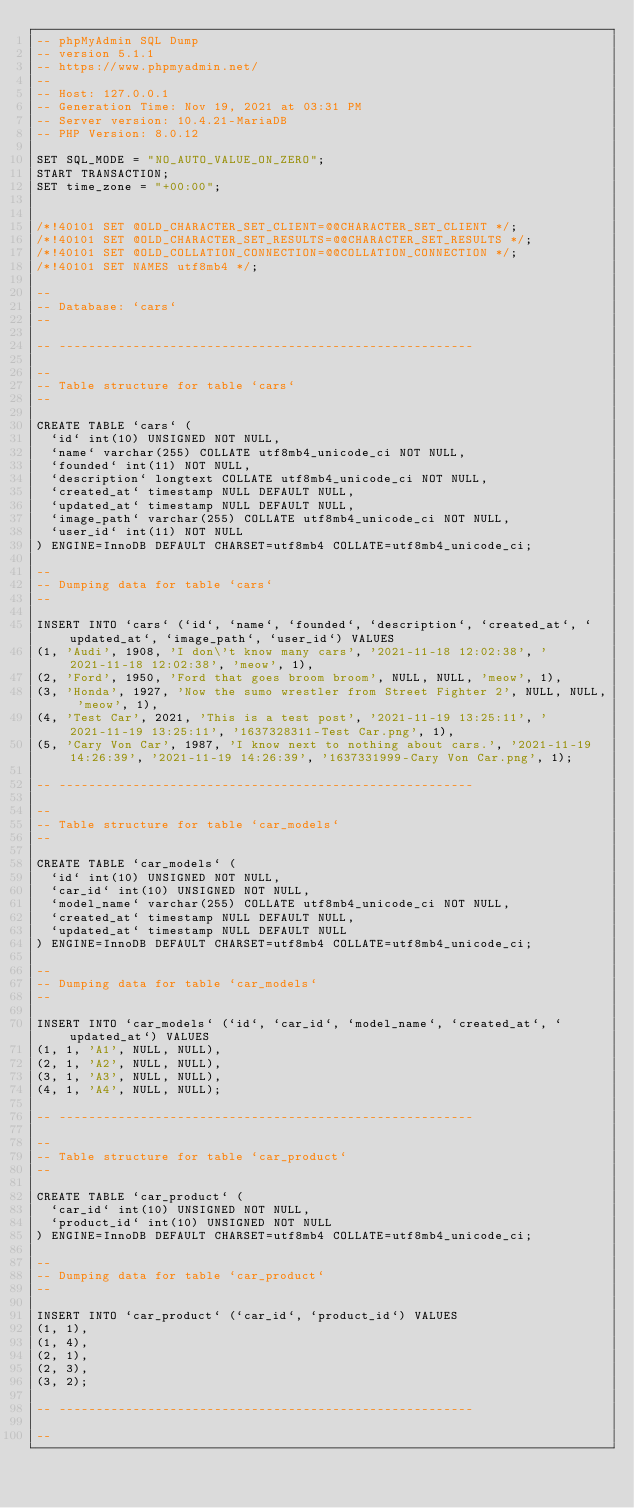Convert code to text. <code><loc_0><loc_0><loc_500><loc_500><_SQL_>-- phpMyAdmin SQL Dump
-- version 5.1.1
-- https://www.phpmyadmin.net/
--
-- Host: 127.0.0.1
-- Generation Time: Nov 19, 2021 at 03:31 PM
-- Server version: 10.4.21-MariaDB
-- PHP Version: 8.0.12

SET SQL_MODE = "NO_AUTO_VALUE_ON_ZERO";
START TRANSACTION;
SET time_zone = "+00:00";


/*!40101 SET @OLD_CHARACTER_SET_CLIENT=@@CHARACTER_SET_CLIENT */;
/*!40101 SET @OLD_CHARACTER_SET_RESULTS=@@CHARACTER_SET_RESULTS */;
/*!40101 SET @OLD_COLLATION_CONNECTION=@@COLLATION_CONNECTION */;
/*!40101 SET NAMES utf8mb4 */;

--
-- Database: `cars`
--

-- --------------------------------------------------------

--
-- Table structure for table `cars`
--

CREATE TABLE `cars` (
  `id` int(10) UNSIGNED NOT NULL,
  `name` varchar(255) COLLATE utf8mb4_unicode_ci NOT NULL,
  `founded` int(11) NOT NULL,
  `description` longtext COLLATE utf8mb4_unicode_ci NOT NULL,
  `created_at` timestamp NULL DEFAULT NULL,
  `updated_at` timestamp NULL DEFAULT NULL,
  `image_path` varchar(255) COLLATE utf8mb4_unicode_ci NOT NULL,
  `user_id` int(11) NOT NULL
) ENGINE=InnoDB DEFAULT CHARSET=utf8mb4 COLLATE=utf8mb4_unicode_ci;

--
-- Dumping data for table `cars`
--

INSERT INTO `cars` (`id`, `name`, `founded`, `description`, `created_at`, `updated_at`, `image_path`, `user_id`) VALUES
(1, 'Audi', 1908, 'I don\'t know many cars', '2021-11-18 12:02:38', '2021-11-18 12:02:38', 'meow', 1),
(2, 'Ford', 1950, 'Ford that goes broom broom', NULL, NULL, 'meow', 1),
(3, 'Honda', 1927, 'Now the sumo wrestler from Street Fighter 2', NULL, NULL, 'meow', 1),
(4, 'Test Car', 2021, 'This is a test post', '2021-11-19 13:25:11', '2021-11-19 13:25:11', '1637328311-Test Car.png', 1),
(5, 'Cary Von Car', 1987, 'I know next to nothing about cars.', '2021-11-19 14:26:39', '2021-11-19 14:26:39', '1637331999-Cary Von Car.png', 1);

-- --------------------------------------------------------

--
-- Table structure for table `car_models`
--

CREATE TABLE `car_models` (
  `id` int(10) UNSIGNED NOT NULL,
  `car_id` int(10) UNSIGNED NOT NULL,
  `model_name` varchar(255) COLLATE utf8mb4_unicode_ci NOT NULL,
  `created_at` timestamp NULL DEFAULT NULL,
  `updated_at` timestamp NULL DEFAULT NULL
) ENGINE=InnoDB DEFAULT CHARSET=utf8mb4 COLLATE=utf8mb4_unicode_ci;

--
-- Dumping data for table `car_models`
--

INSERT INTO `car_models` (`id`, `car_id`, `model_name`, `created_at`, `updated_at`) VALUES
(1, 1, 'A1', NULL, NULL),
(2, 1, 'A2', NULL, NULL),
(3, 1, 'A3', NULL, NULL),
(4, 1, 'A4', NULL, NULL);

-- --------------------------------------------------------

--
-- Table structure for table `car_product`
--

CREATE TABLE `car_product` (
  `car_id` int(10) UNSIGNED NOT NULL,
  `product_id` int(10) UNSIGNED NOT NULL
) ENGINE=InnoDB DEFAULT CHARSET=utf8mb4 COLLATE=utf8mb4_unicode_ci;

--
-- Dumping data for table `car_product`
--

INSERT INTO `car_product` (`car_id`, `product_id`) VALUES
(1, 1),
(1, 4),
(2, 1),
(2, 3),
(3, 2);

-- --------------------------------------------------------

--</code> 